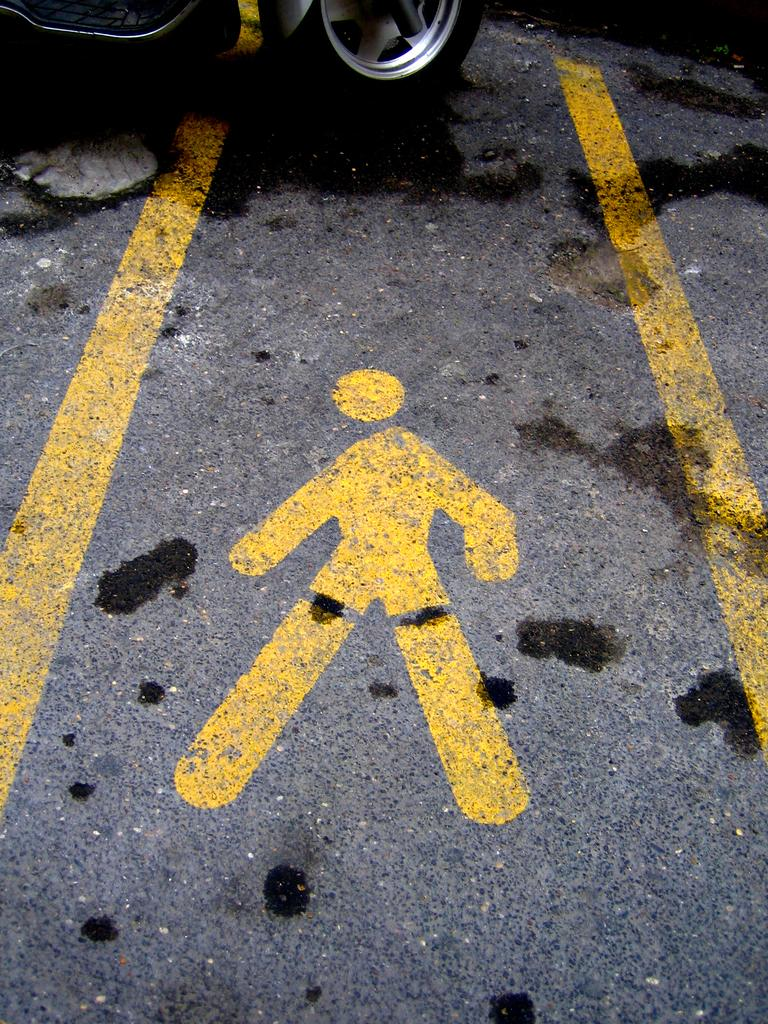What is the main feature of the image? There is a road in the image. What can be seen on the road? There is a yellow line on the road and a diagram. What else is present in the image? A vehicle is visible in the image. Can you see the sisters walking along the road in the image? There are no sisters or any indication of people walking in the image; it only shows a road with a yellow line, a diagram, and a vehicle. 